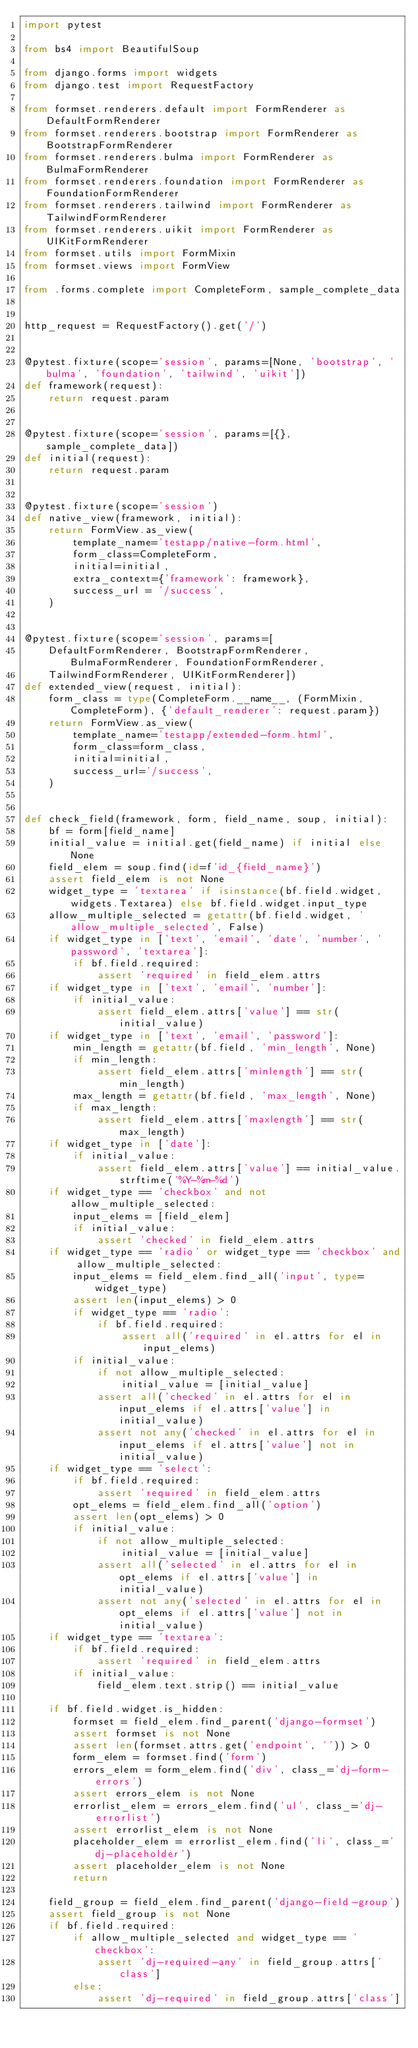Convert code to text. <code><loc_0><loc_0><loc_500><loc_500><_Python_>import pytest

from bs4 import BeautifulSoup

from django.forms import widgets
from django.test import RequestFactory

from formset.renderers.default import FormRenderer as DefaultFormRenderer
from formset.renderers.bootstrap import FormRenderer as BootstrapFormRenderer
from formset.renderers.bulma import FormRenderer as BulmaFormRenderer
from formset.renderers.foundation import FormRenderer as FoundationFormRenderer
from formset.renderers.tailwind import FormRenderer as TailwindFormRenderer
from formset.renderers.uikit import FormRenderer as UIKitFormRenderer
from formset.utils import FormMixin
from formset.views import FormView

from .forms.complete import CompleteForm, sample_complete_data


http_request = RequestFactory().get('/')


@pytest.fixture(scope='session', params=[None, 'bootstrap', 'bulma', 'foundation', 'tailwind', 'uikit'])
def framework(request):
    return request.param


@pytest.fixture(scope='session', params=[{}, sample_complete_data])
def initial(request):
    return request.param


@pytest.fixture(scope='session')
def native_view(framework, initial):
    return FormView.as_view(
        template_name='testapp/native-form.html',
        form_class=CompleteForm,
        initial=initial,
        extra_context={'framework': framework},
        success_url = '/success',
    )


@pytest.fixture(scope='session', params=[
    DefaultFormRenderer, BootstrapFormRenderer, BulmaFormRenderer, FoundationFormRenderer,
    TailwindFormRenderer, UIKitFormRenderer])
def extended_view(request, initial):
    form_class = type(CompleteForm.__name__, (FormMixin, CompleteForm), {'default_renderer': request.param})
    return FormView.as_view(
        template_name='testapp/extended-form.html',
        form_class=form_class,
        initial=initial,
        success_url='/success',
    )


def check_field(framework, form, field_name, soup, initial):
    bf = form[field_name]
    initial_value = initial.get(field_name) if initial else None
    field_elem = soup.find(id=f'id_{field_name}')
    assert field_elem is not None
    widget_type = 'textarea' if isinstance(bf.field.widget, widgets.Textarea) else bf.field.widget.input_type
    allow_multiple_selected = getattr(bf.field.widget, 'allow_multiple_selected', False)
    if widget_type in ['text', 'email', 'date', 'number', 'password', 'textarea']:
        if bf.field.required:
            assert 'required' in field_elem.attrs
    if widget_type in ['text', 'email', 'number']:
        if initial_value:
            assert field_elem.attrs['value'] == str(initial_value)
    if widget_type in ['text', 'email', 'password']:
        min_length = getattr(bf.field, 'min_length', None)
        if min_length:
            assert field_elem.attrs['minlength'] == str(min_length)
        max_length = getattr(bf.field, 'max_length', None)
        if max_length:
            assert field_elem.attrs['maxlength'] == str(max_length)
    if widget_type in ['date']:
        if initial_value:
            assert field_elem.attrs['value'] == initial_value.strftime('%Y-%m-%d')
    if widget_type == 'checkbox' and not allow_multiple_selected:
        input_elems = [field_elem]
        if initial_value:
            assert 'checked' in field_elem.attrs
    if widget_type == 'radio' or widget_type == 'checkbox' and allow_multiple_selected:
        input_elems = field_elem.find_all('input', type=widget_type)
        assert len(input_elems) > 0
        if widget_type == 'radio':
            if bf.field.required:
                assert all('required' in el.attrs for el in input_elems)
        if initial_value:
            if not allow_multiple_selected:
                initial_value = [initial_value]
            assert all('checked' in el.attrs for el in input_elems if el.attrs['value'] in initial_value)
            assert not any('checked' in el.attrs for el in input_elems if el.attrs['value'] not in initial_value)
    if widget_type == 'select':
        if bf.field.required:
            assert 'required' in field_elem.attrs
        opt_elems = field_elem.find_all('option')
        assert len(opt_elems) > 0
        if initial_value:
            if not allow_multiple_selected:
                initial_value = [initial_value]
            assert all('selected' in el.attrs for el in opt_elems if el.attrs['value'] in initial_value)
            assert not any('selected' in el.attrs for el in opt_elems if el.attrs['value'] not in initial_value)
    if widget_type == 'textarea':
        if bf.field.required:
            assert 'required' in field_elem.attrs
        if initial_value:
            field_elem.text.strip() == initial_value

    if bf.field.widget.is_hidden:
        formset = field_elem.find_parent('django-formset')
        assert formset is not None
        assert len(formset.attrs.get('endpoint', '')) > 0
        form_elem = formset.find('form')
        errors_elem = form_elem.find('div', class_='dj-form-errors')
        assert errors_elem is not None
        errorlist_elem = errors_elem.find('ul', class_='dj-errorlist')
        assert errorlist_elem is not None
        placeholder_elem = errorlist_elem.find('li', class_='dj-placeholder')
        assert placeholder_elem is not None
        return

    field_group = field_elem.find_parent('django-field-group')
    assert field_group is not None
    if bf.field.required:
        if allow_multiple_selected and widget_type == 'checkbox':
            assert 'dj-required-any' in field_group.attrs['class']
        else:
            assert 'dj-required' in field_group.attrs['class']</code> 